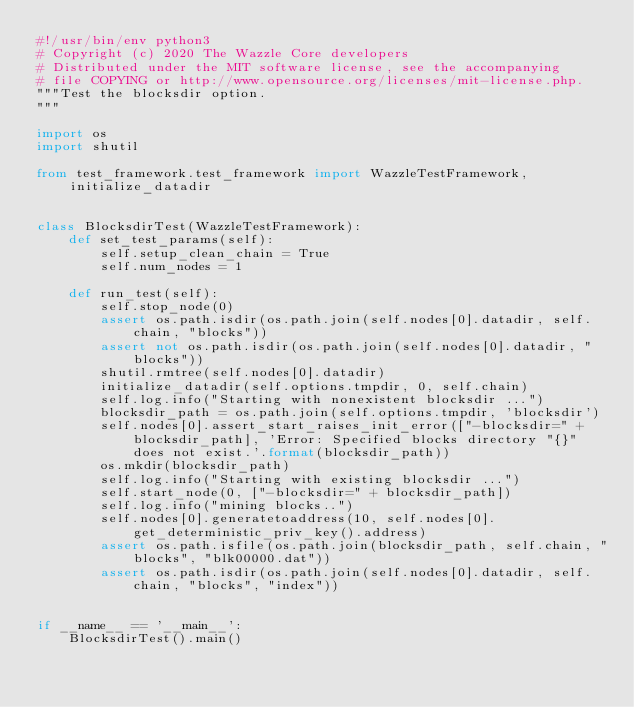Convert code to text. <code><loc_0><loc_0><loc_500><loc_500><_Python_>#!/usr/bin/env python3
# Copyright (c) 2020 The Wazzle Core developers
# Distributed under the MIT software license, see the accompanying
# file COPYING or http://www.opensource.org/licenses/mit-license.php.
"""Test the blocksdir option.
"""

import os
import shutil

from test_framework.test_framework import WazzleTestFramework, initialize_datadir


class BlocksdirTest(WazzleTestFramework):
    def set_test_params(self):
        self.setup_clean_chain = True
        self.num_nodes = 1

    def run_test(self):
        self.stop_node(0)
        assert os.path.isdir(os.path.join(self.nodes[0].datadir, self.chain, "blocks"))
        assert not os.path.isdir(os.path.join(self.nodes[0].datadir, "blocks"))
        shutil.rmtree(self.nodes[0].datadir)
        initialize_datadir(self.options.tmpdir, 0, self.chain)
        self.log.info("Starting with nonexistent blocksdir ...")
        blocksdir_path = os.path.join(self.options.tmpdir, 'blocksdir')
        self.nodes[0].assert_start_raises_init_error(["-blocksdir=" + blocksdir_path], 'Error: Specified blocks directory "{}" does not exist.'.format(blocksdir_path))
        os.mkdir(blocksdir_path)
        self.log.info("Starting with existing blocksdir ...")
        self.start_node(0, ["-blocksdir=" + blocksdir_path])
        self.log.info("mining blocks..")
        self.nodes[0].generatetoaddress(10, self.nodes[0].get_deterministic_priv_key().address)
        assert os.path.isfile(os.path.join(blocksdir_path, self.chain, "blocks", "blk00000.dat"))
        assert os.path.isdir(os.path.join(self.nodes[0].datadir, self.chain, "blocks", "index"))


if __name__ == '__main__':
    BlocksdirTest().main()
</code> 